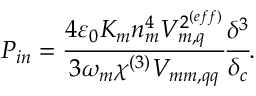<formula> <loc_0><loc_0><loc_500><loc_500>P _ { i n } = \cfrac { 4 \varepsilon _ { 0 } K _ { m } n _ { m } ^ { 4 } V _ { m , q } ^ { 2 ^ { ( e f f ) } } } { 3 \omega _ { m } \chi ^ { ( 3 ) } V _ { m m , q q } } \cfrac { \delta ^ { 3 } } { \delta _ { c } } .</formula> 